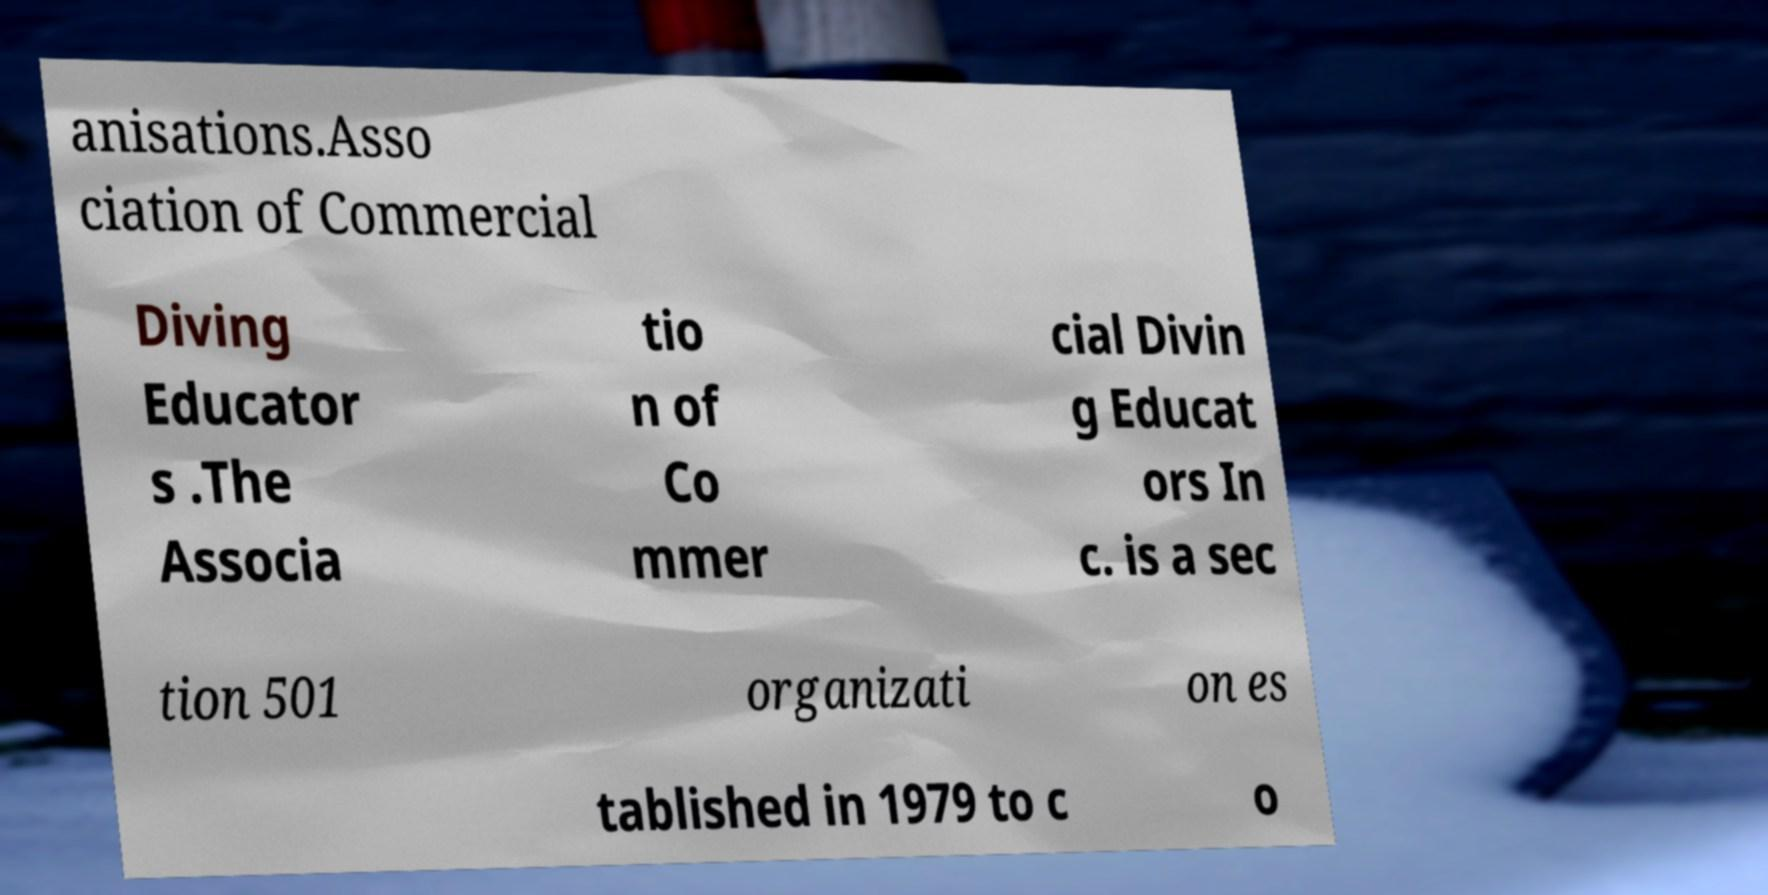I need the written content from this picture converted into text. Can you do that? anisations.Asso ciation of Commercial Diving Educator s .The Associa tio n of Co mmer cial Divin g Educat ors In c. is a sec tion 501 organizati on es tablished in 1979 to c o 